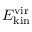<formula> <loc_0><loc_0><loc_500><loc_500>E _ { k i n } ^ { v i r }</formula> 